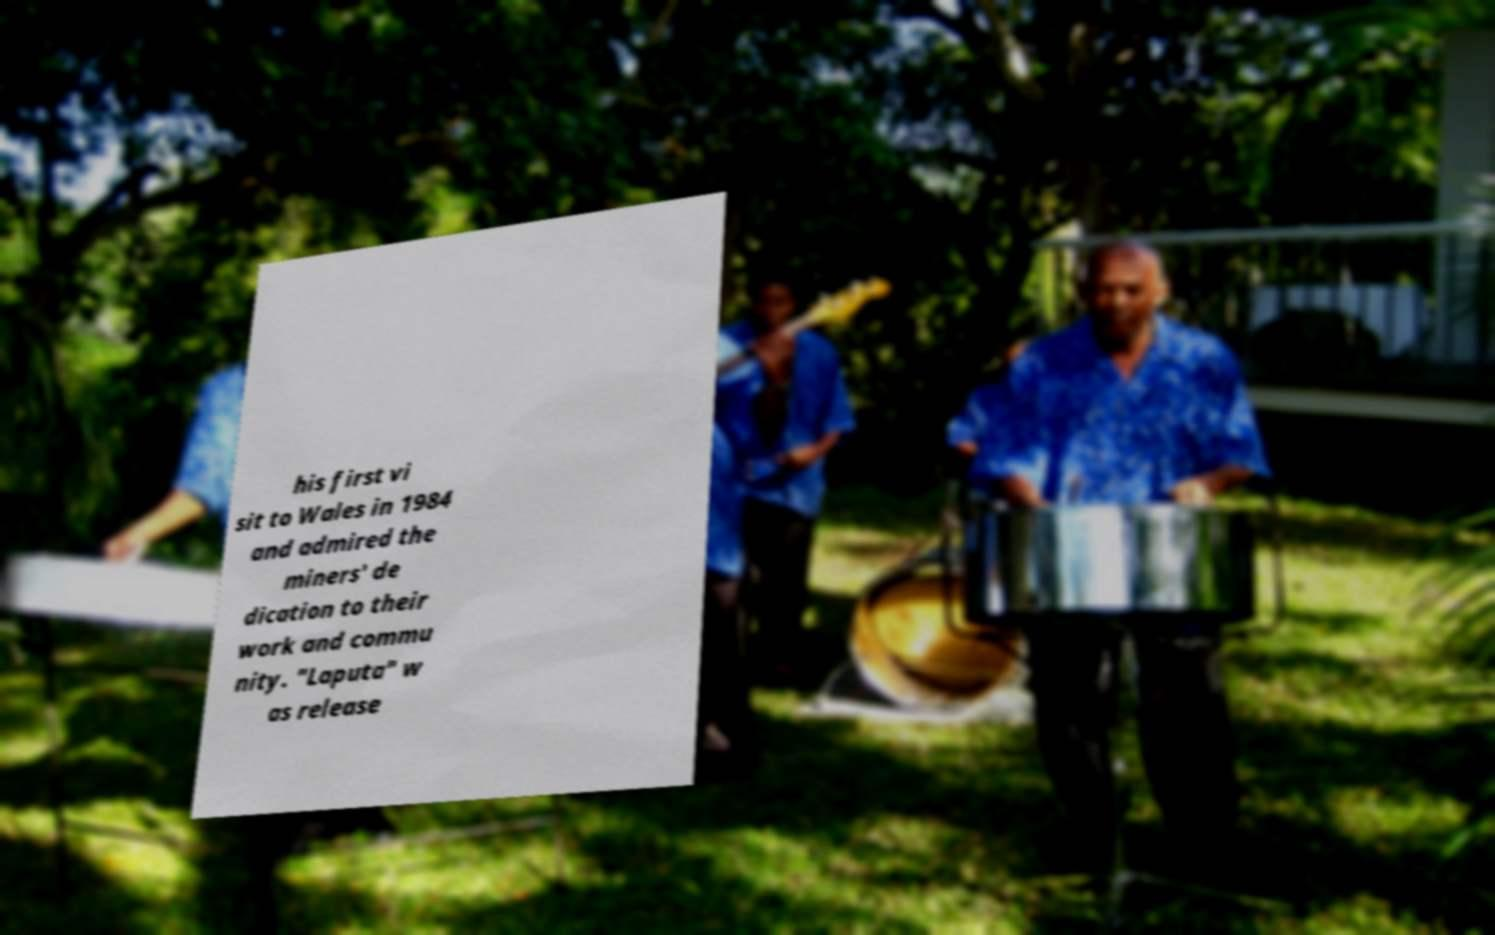Please identify and transcribe the text found in this image. his first vi sit to Wales in 1984 and admired the miners' de dication to their work and commu nity. "Laputa" w as release 